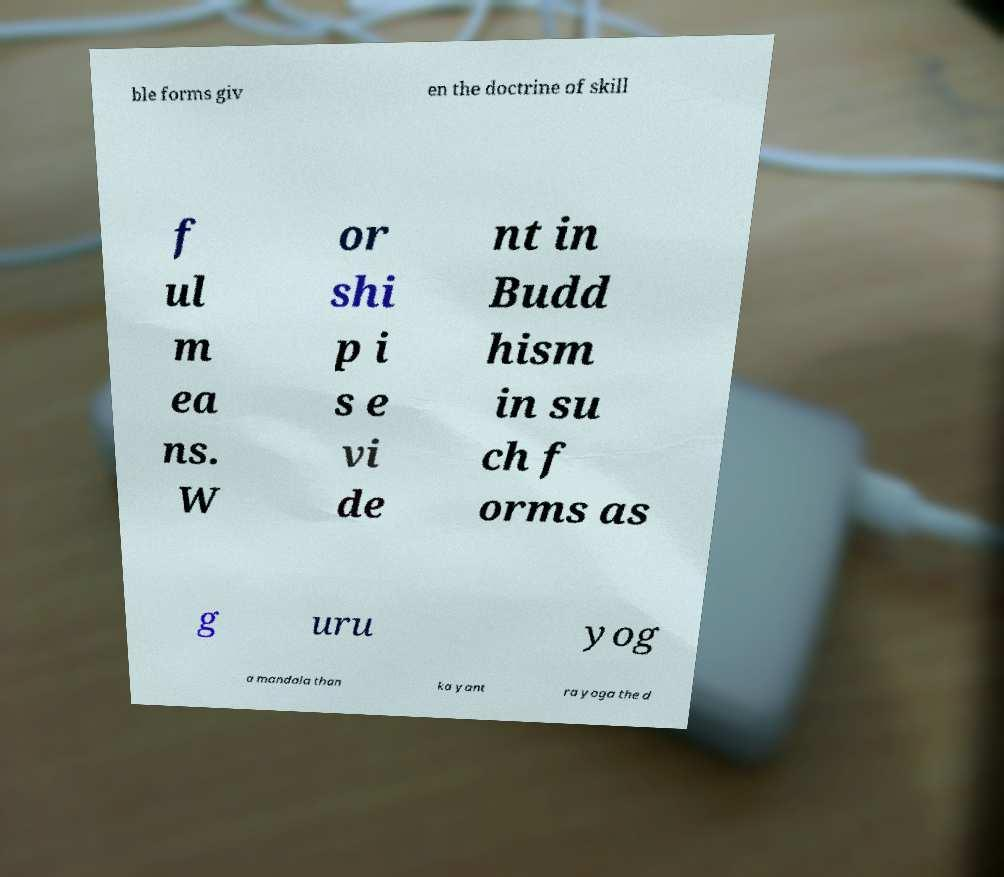Could you extract and type out the text from this image? ble forms giv en the doctrine of skill f ul m ea ns. W or shi p i s e vi de nt in Budd hism in su ch f orms as g uru yog a mandala than ka yant ra yoga the d 